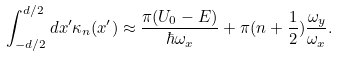<formula> <loc_0><loc_0><loc_500><loc_500>\int _ { - d / 2 } ^ { d / 2 } d x ^ { \prime } \kappa _ { n } ( x ^ { \prime } ) \approx \frac { \pi ( U _ { 0 } - E ) } { \hbar { \omega } _ { x } } + \pi ( n + \frac { 1 } { 2 } ) \frac { \omega _ { y } } { \omega _ { x } } .</formula> 